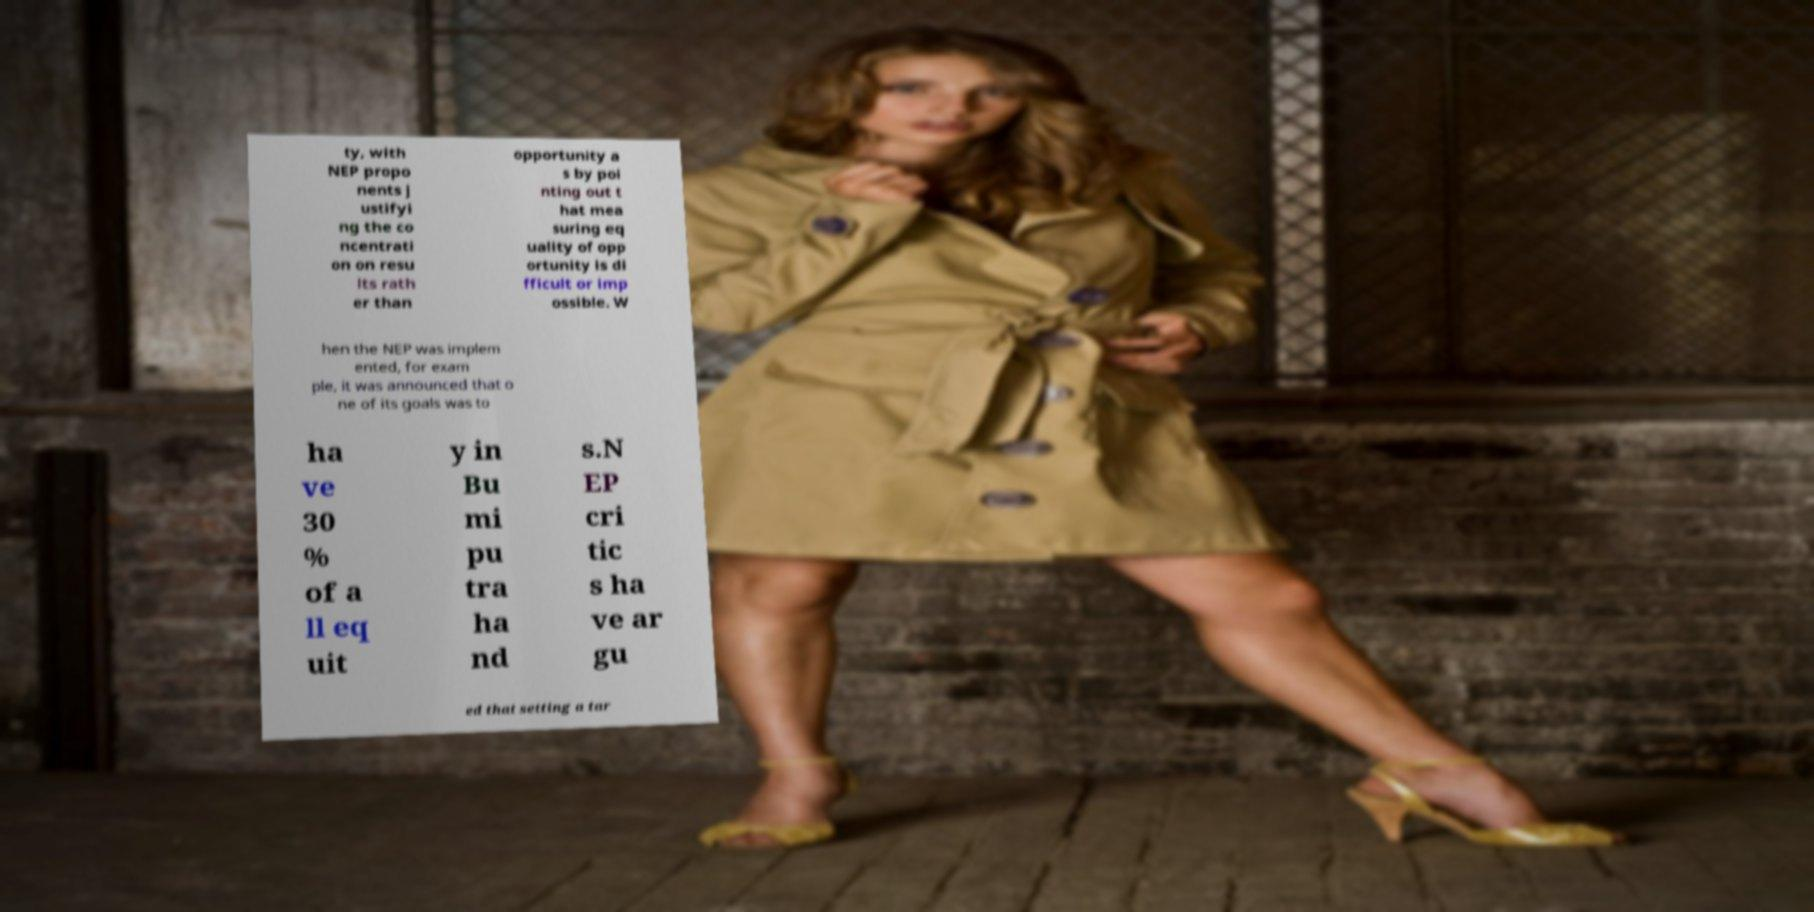Can you accurately transcribe the text from the provided image for me? ty, with NEP propo nents j ustifyi ng the co ncentrati on on resu lts rath er than opportunity a s by poi nting out t hat mea suring eq uality of opp ortunity is di fficult or imp ossible. W hen the NEP was implem ented, for exam ple, it was announced that o ne of its goals was to ha ve 30 % of a ll eq uit y in Bu mi pu tra ha nd s.N EP cri tic s ha ve ar gu ed that setting a tar 